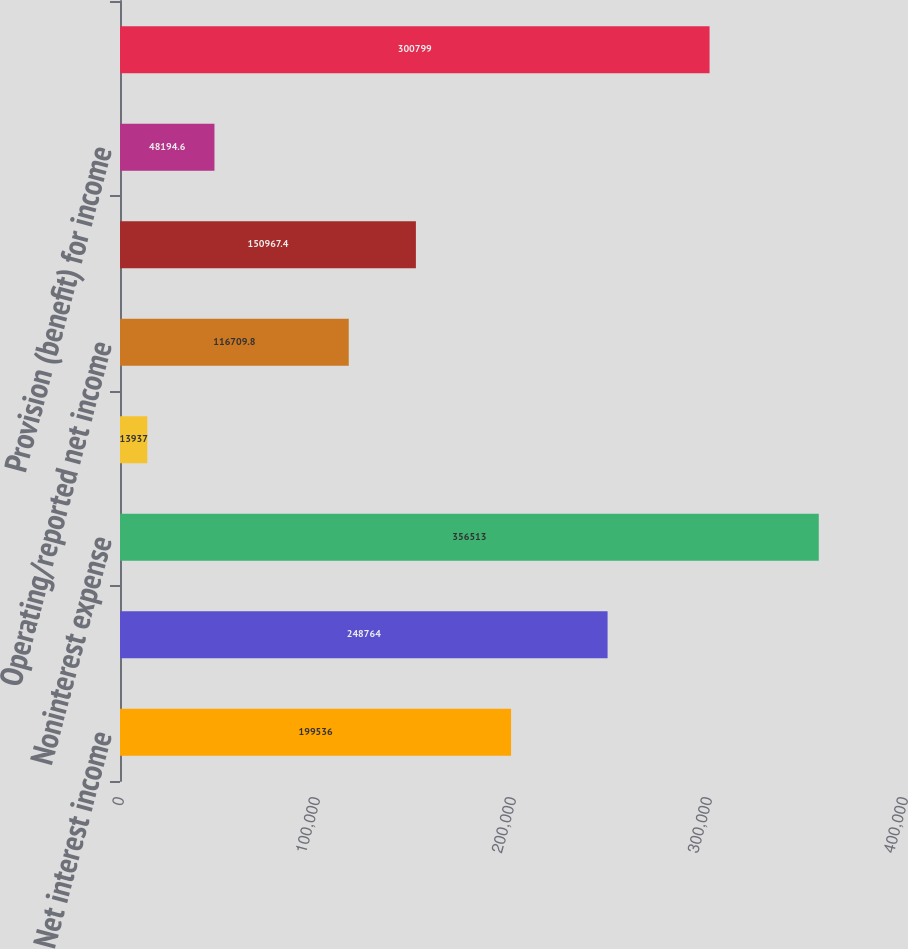Convert chart. <chart><loc_0><loc_0><loc_500><loc_500><bar_chart><fcel>Net interest income<fcel>Noninterest income<fcel>Noninterest expense<fcel>Provision for income taxes<fcel>Operating/reported net income<fcel>Provision for credit losses<fcel>Provision (benefit) for income<fcel>excluding goodwill impairment<nl><fcel>199536<fcel>248764<fcel>356513<fcel>13937<fcel>116710<fcel>150967<fcel>48194.6<fcel>300799<nl></chart> 